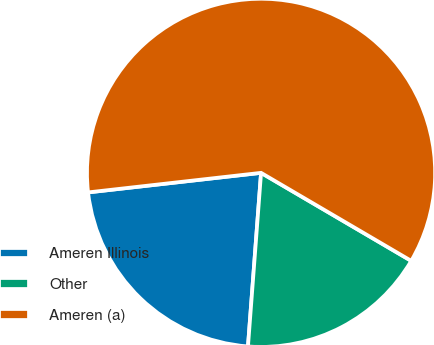Convert chart to OTSL. <chart><loc_0><loc_0><loc_500><loc_500><pie_chart><fcel>Ameren Illinois<fcel>Other<fcel>Ameren (a)<nl><fcel>22.01%<fcel>17.76%<fcel>60.23%<nl></chart> 